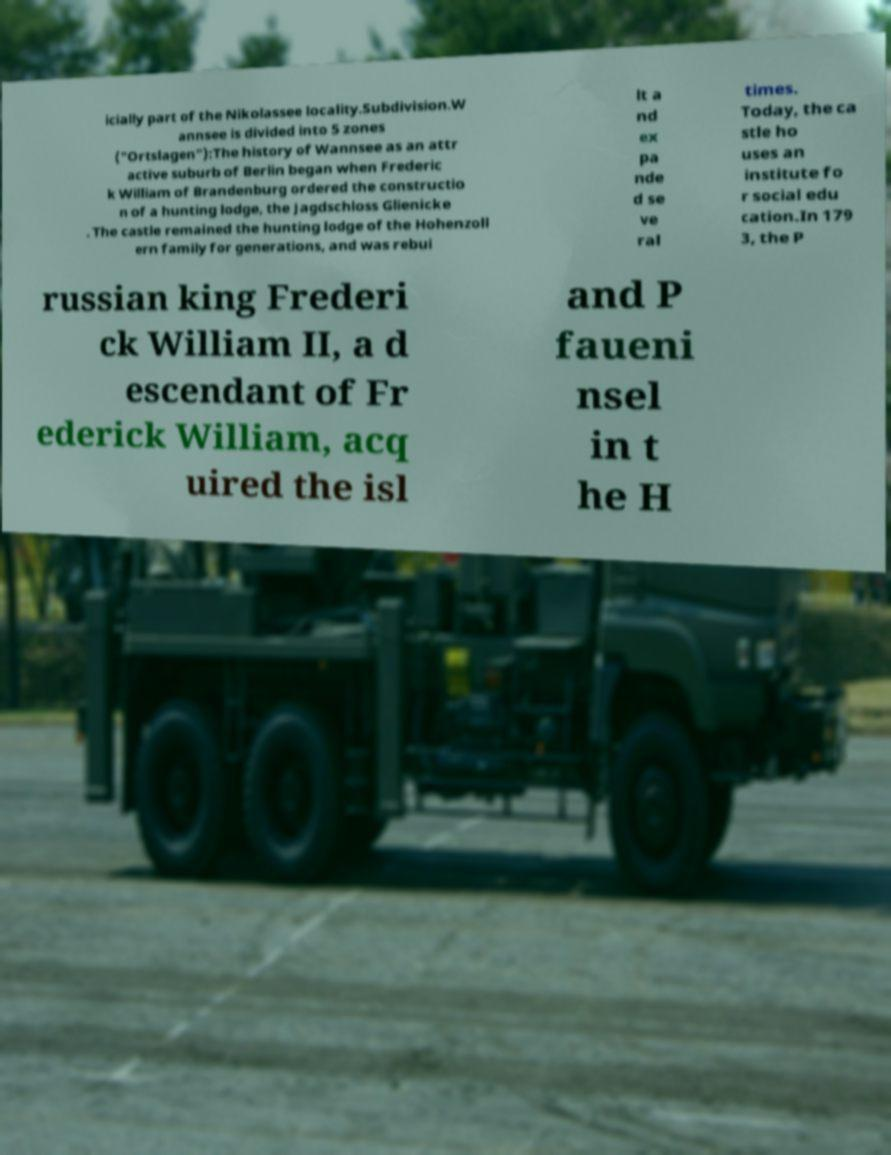Could you extract and type out the text from this image? icially part of the Nikolassee locality.Subdivision.W annsee is divided into 5 zones ("Ortslagen"):The history of Wannsee as an attr active suburb of Berlin began when Frederic k William of Brandenburg ordered the constructio n of a hunting lodge, the Jagdschloss Glienicke . The castle remained the hunting lodge of the Hohenzoll ern family for generations, and was rebui lt a nd ex pa nde d se ve ral times. Today, the ca stle ho uses an institute fo r social edu cation.In 179 3, the P russian king Frederi ck William II, a d escendant of Fr ederick William, acq uired the isl and P faueni nsel in t he H 